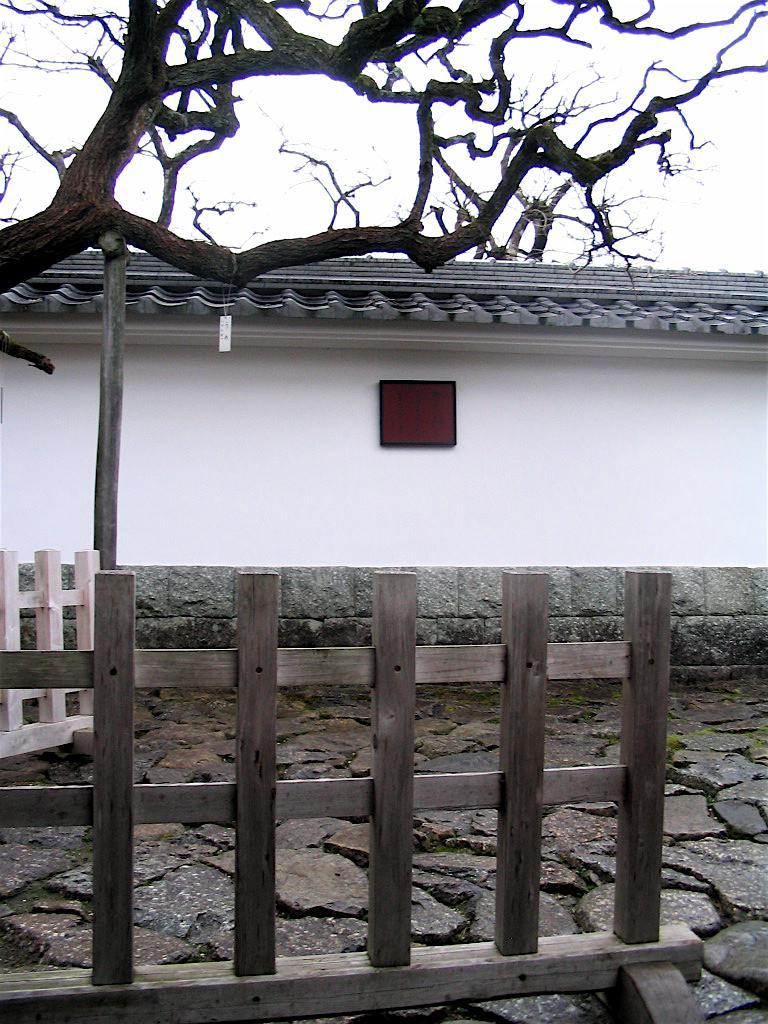What type of structure is present in the image? There is a house in the image. What material are the railings made of in the image? The railings in the image are made of wood. What type of plant can be seen in the image? There is a tree in the image. What is visible in the background of the image? The sky is visible in the image. What type of space suit is the astronaut wearing in the image? There is no astronaut or space suit present in the image; it features a house, wooden railings, a tree, and the sky. 